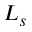<formula> <loc_0><loc_0><loc_500><loc_500>L _ { s }</formula> 